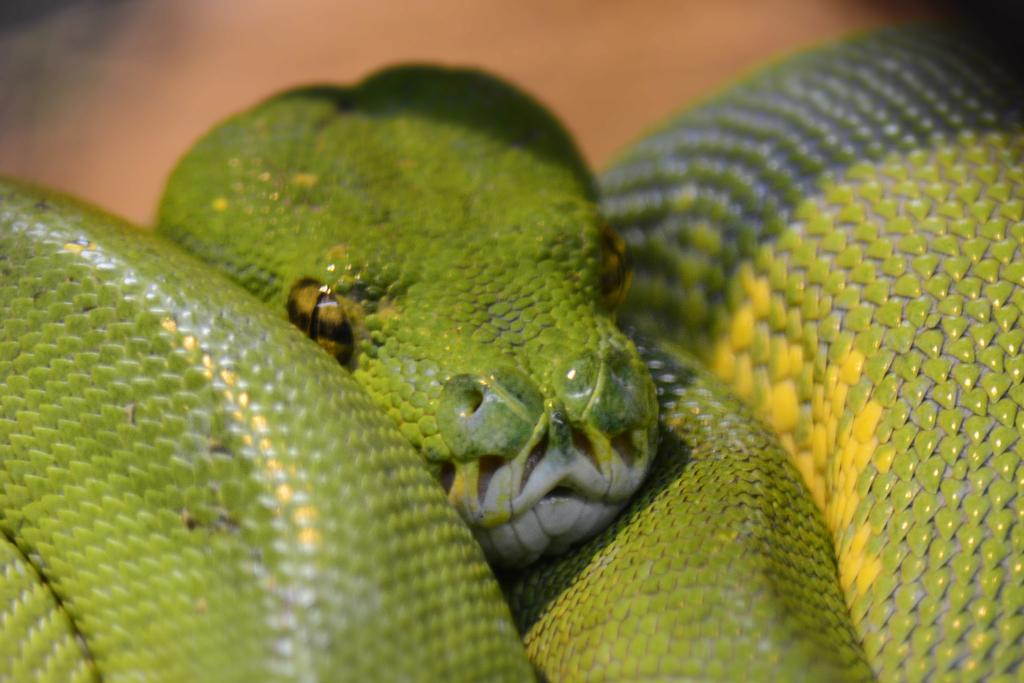What type of animal is present in the image? There is a snake in the image. What type of vest is the snake wearing in the image? There is no vest present in the image, as snakes do not wear clothing. 